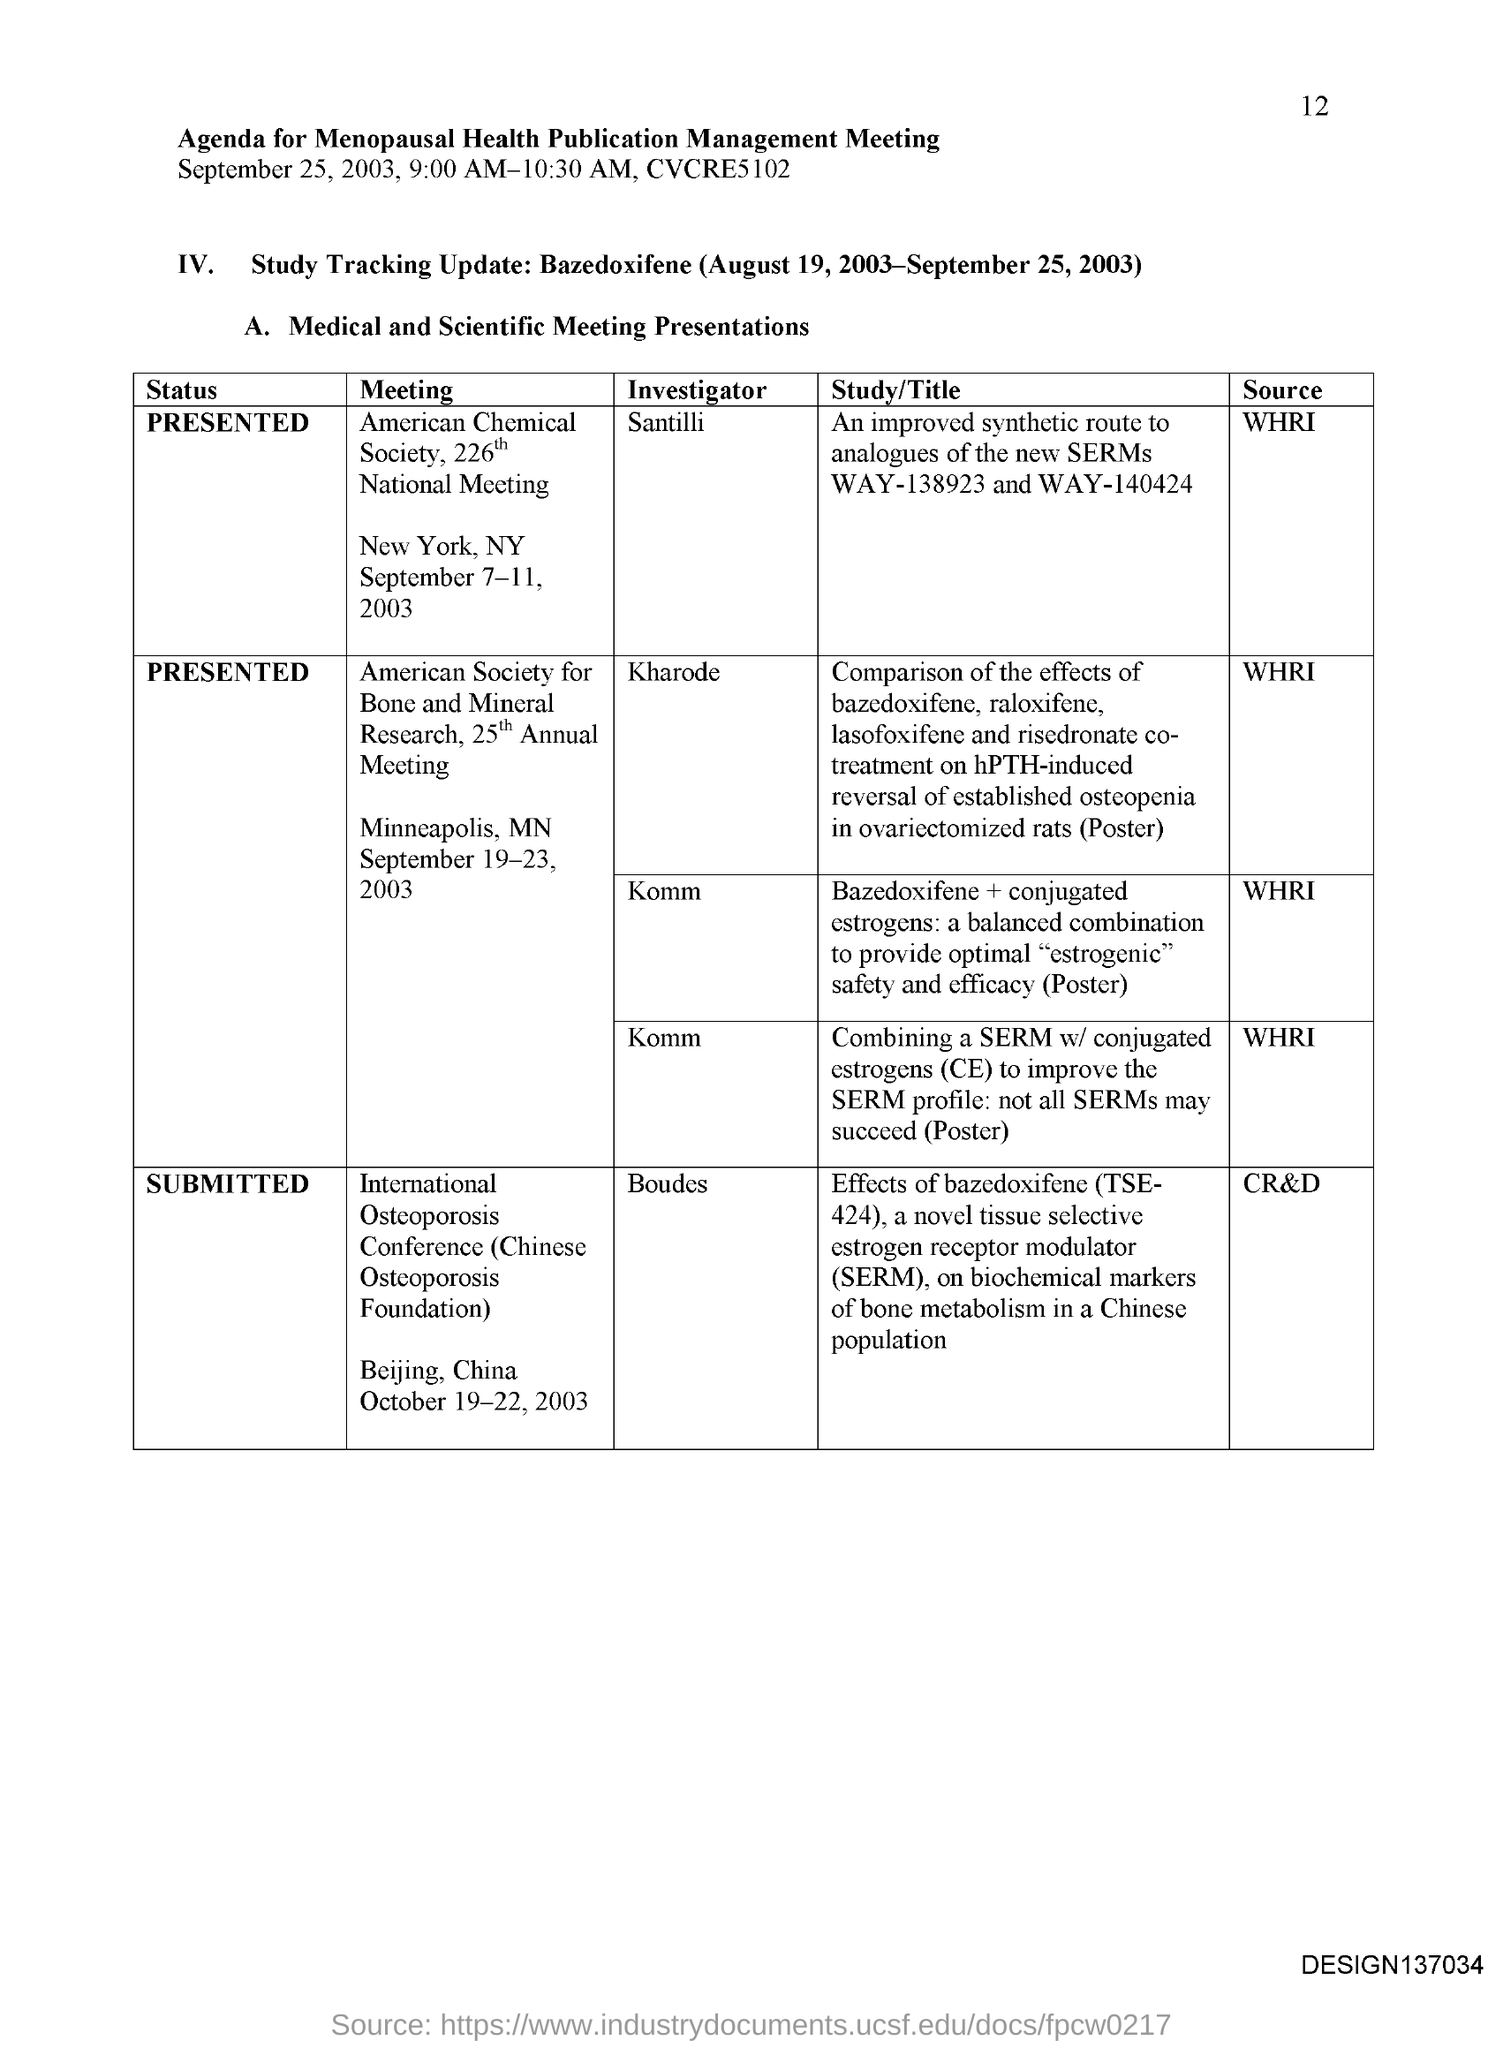What is the Page Number?
Your response must be concise. 12. Who is the Investigator of the American Chemical Society, 226th National Meeting?
Provide a short and direct response. Santilli. What is the status of the "International Osteoporosis Conference"?
Your answer should be very brief. Submitted. What is the status of the "American Society for Bone and Mineral Research, 25th Annual Meeting"?
Offer a terse response. Presented. What is the status of the "American Chemical Society, 226th National Meeting"?
Keep it short and to the point. Presented. 